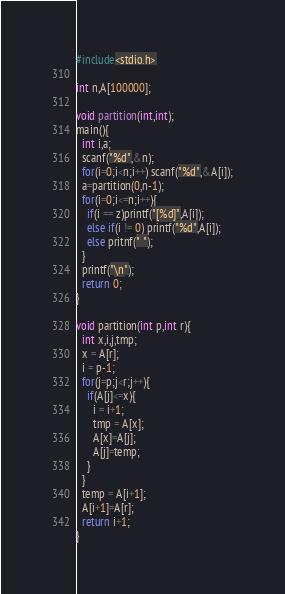Convert code to text. <code><loc_0><loc_0><loc_500><loc_500><_C_>#include<stdio.h>

int n,A[100000];

void partition(int,int);
main(){
  int i,a;
  scanf("%d",&n);
  for(i=0;i<n;i++) scanf("%d",&A[i]);
  a=partition(0,n-1);
  for(i=0;i<=n;i++){
    if(i == z)printf("[%d]",A[i]);
    else if(i != 0) printf("%d",A[i]);
    else pritnf(" ");
  }
  printf("\n");
  return 0;
}

void partition(int p,int r){
  int x,i,j,tmp;
  x = A[r];
  i = p-1;
  for(j=p;j<r;j++){
    if(A[j]<=x){
      i = i+1;
      tmp = A[x];
      A[x]=A[j];
      A[j]=temp;
    }
  }
  temp = A[i+1];
  A[i+1]=A[r];
  return i+1;
}</code> 